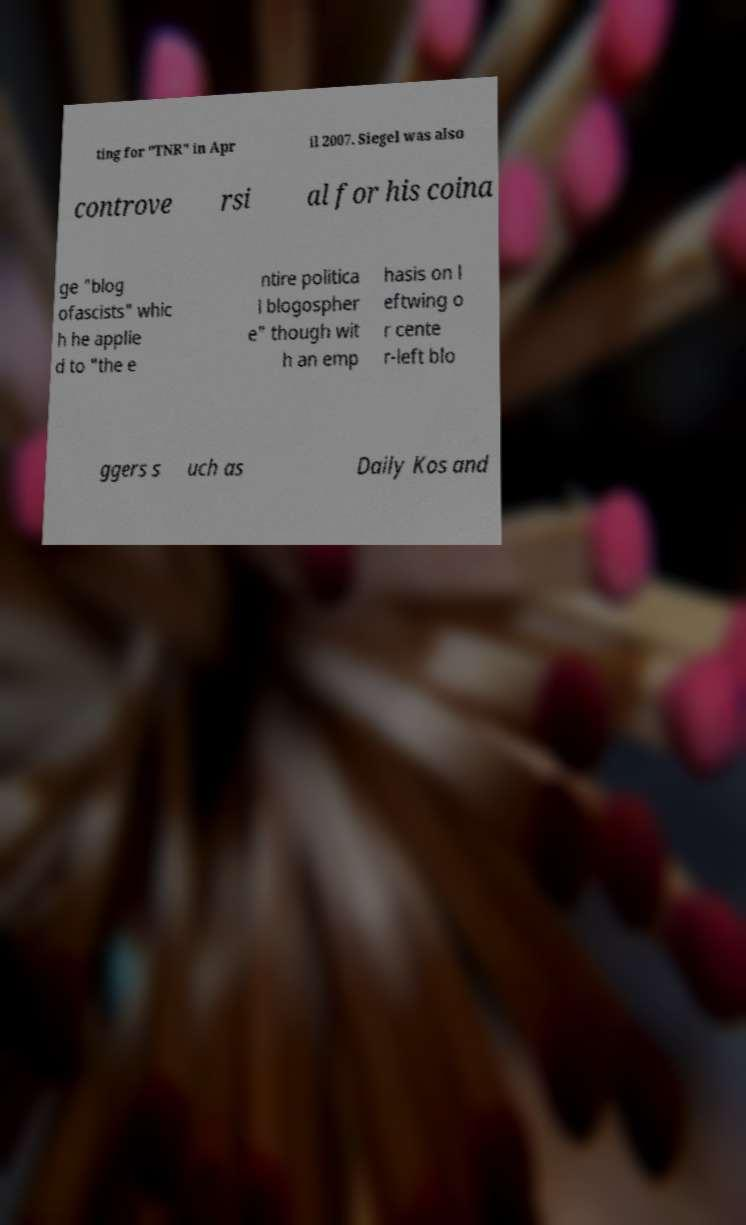I need the written content from this picture converted into text. Can you do that? ting for "TNR" in Apr il 2007. Siegel was also controve rsi al for his coina ge "blog ofascists" whic h he applie d to "the e ntire politica l blogospher e" though wit h an emp hasis on l eftwing o r cente r-left blo ggers s uch as Daily Kos and 